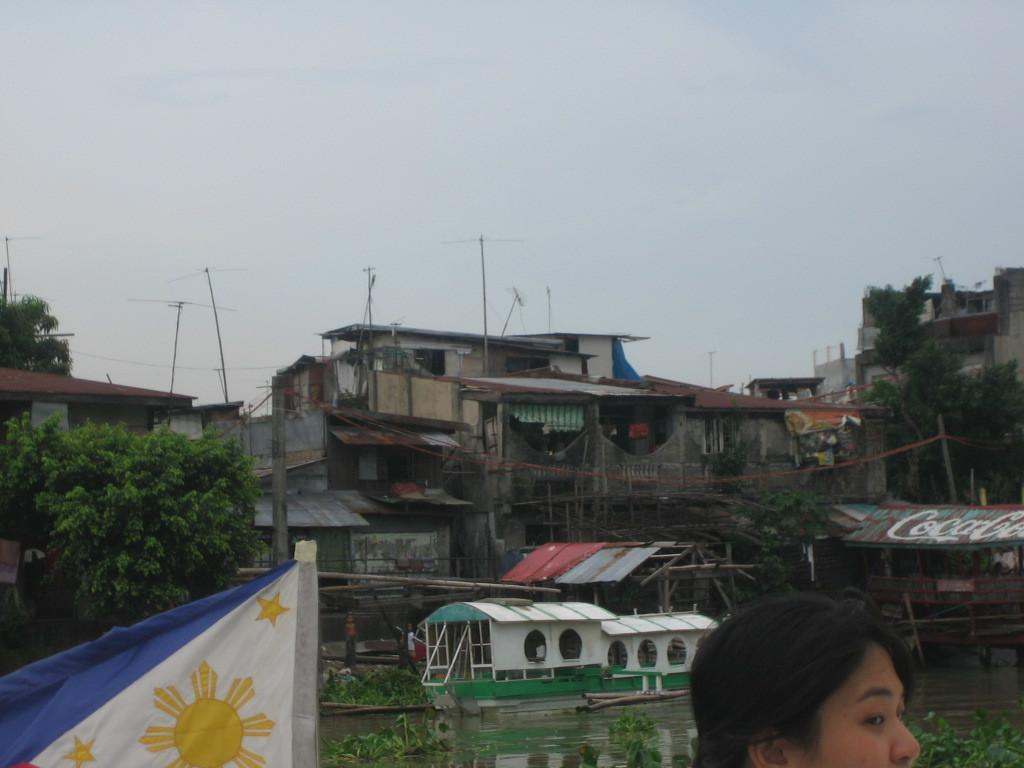What is on the water in the image? There are boats on the water in the image. What type of structures can be seen in the image? There are houses visible in the image. What type of vegetation is present in the image? There are trees in the image. What is visible in the sky in the image? Clouds are present in the sky in the image. Can you identify any human features in the image? The head of a person is visible in the image. What type of pest can be seen crawling on the boats in the image? There is no pest present on the boats in the image. How does the person in the image express disgust? There is no indication of disgust in the image, as only the head of a person is visible. 